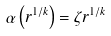<formula> <loc_0><loc_0><loc_500><loc_500>\alpha \left ( r ^ { 1 / k } \right ) = \zeta r ^ { 1 / k }</formula> 